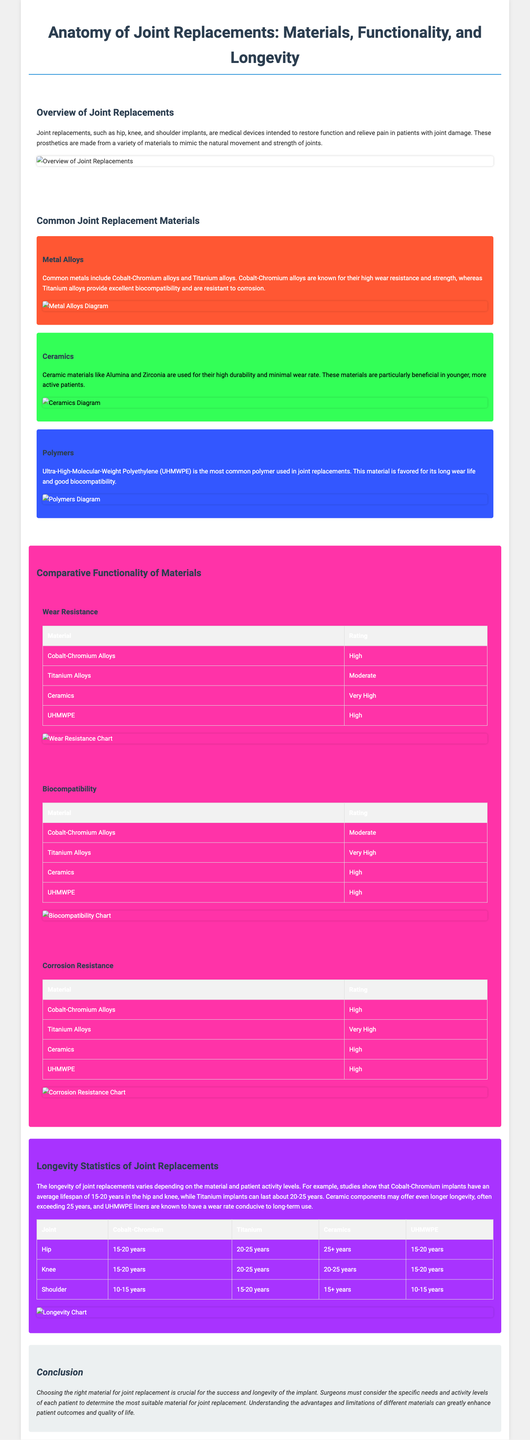What is the primary purpose of joint replacements? The primary purpose of joint replacements is to restore function and relieve pain in patients with joint damage.
Answer: Restore function and relieve pain Which metal alloy is known for high wear resistance? Cobalt-Chromium alloys are known for their high wear resistance.
Answer: Cobalt-Chromium alloys What is the average lifespan of Titanium implants in years? Titanium implants have an average lifespan of 20-25 years.
Answer: 20-25 years Which material offers minimal wear rate and is beneficial for younger patients? Ceramic materials like Alumina and Zirconia offer minimal wear rate and are beneficial for younger patients.
Answer: Ceramic materials What rating do Titanium alloys have for biocompatibility? Titanium alloys have a rating of Very High for biocompatibility.
Answer: Very High How many years do Cobalt-Chromium hip implants typically last? Cobalt-Chromium hip implants typically last 15-20 years.
Answer: 15-20 years What is the background color for the ceramics section? The background color for the ceramics section is green.
Answer: Green Which joint has the shortest average lifespan for Cobalt-Chromium implants? The shoulder joint has the shortest average lifespan for Cobalt-Chromium implants.
Answer: Shoulder What type of charts are included in the comparative functionality section? The charts in the comparative functionality section include wear resistance, biocompatibility, and corrosion resistance charts.
Answer: Wear resistance, biocompatibility, and corrosion resistance charts 